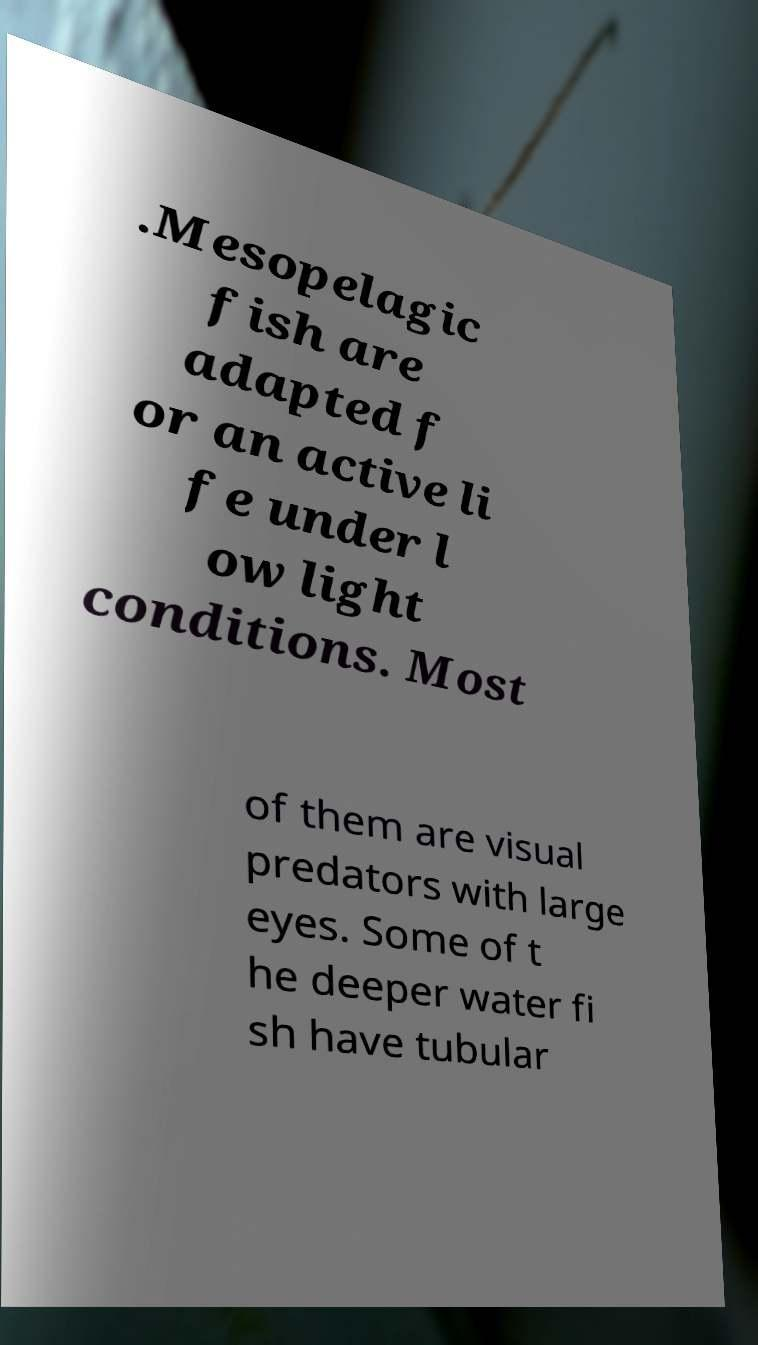Could you extract and type out the text from this image? .Mesopelagic fish are adapted f or an active li fe under l ow light conditions. Most of them are visual predators with large eyes. Some of t he deeper water fi sh have tubular 